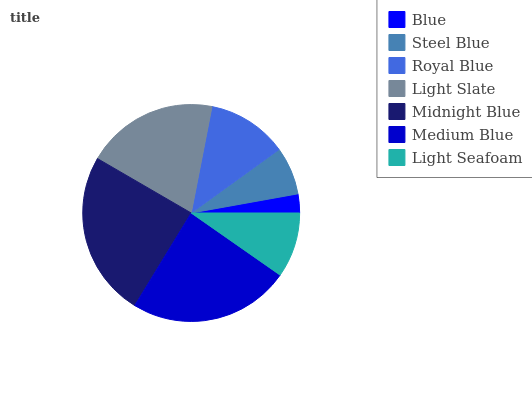Is Blue the minimum?
Answer yes or no. Yes. Is Midnight Blue the maximum?
Answer yes or no. Yes. Is Steel Blue the minimum?
Answer yes or no. No. Is Steel Blue the maximum?
Answer yes or no. No. Is Steel Blue greater than Blue?
Answer yes or no. Yes. Is Blue less than Steel Blue?
Answer yes or no. Yes. Is Blue greater than Steel Blue?
Answer yes or no. No. Is Steel Blue less than Blue?
Answer yes or no. No. Is Royal Blue the high median?
Answer yes or no. Yes. Is Royal Blue the low median?
Answer yes or no. Yes. Is Light Slate the high median?
Answer yes or no. No. Is Light Seafoam the low median?
Answer yes or no. No. 